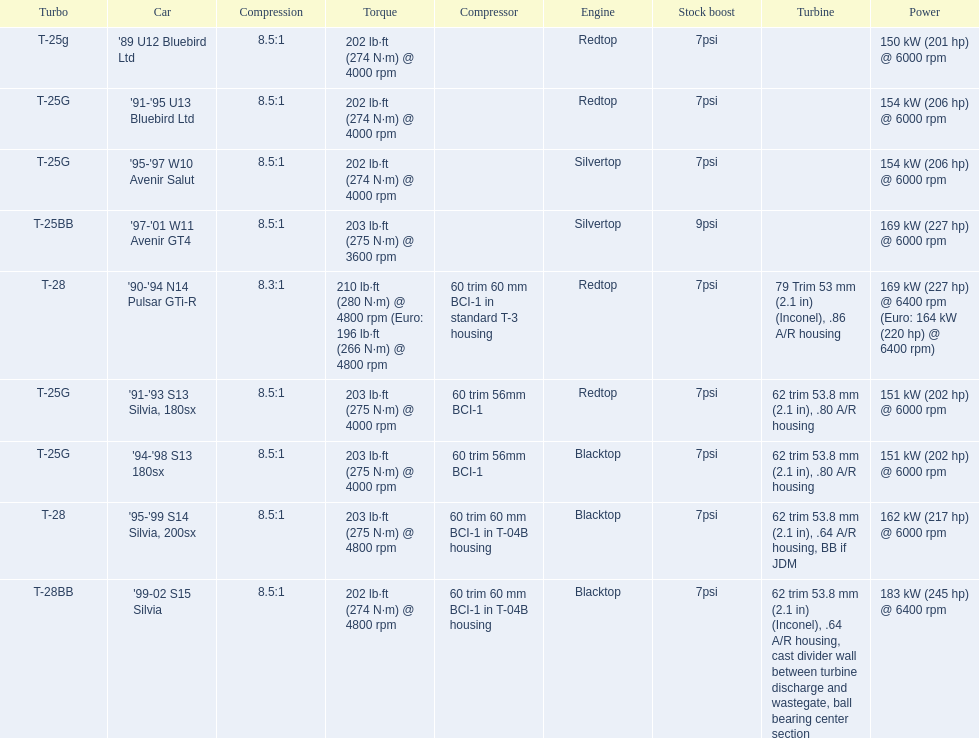Which cars featured blacktop engines? '94-'98 S13 180sx, '95-'99 S14 Silvia, 200sx, '99-02 S15 Silvia. Which of these had t-04b compressor housings? '95-'99 S14 Silvia, 200sx, '99-02 S15 Silvia. Which one of these has the highest horsepower? '99-02 S15 Silvia. 